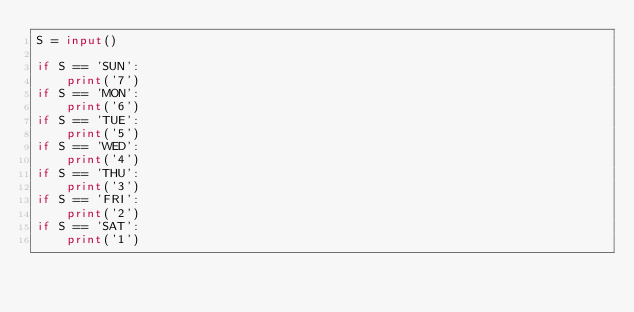Convert code to text. <code><loc_0><loc_0><loc_500><loc_500><_Python_>S = input()

if S == 'SUN':
    print('7')
if S == 'MON':
    print('6')
if S == 'TUE':
    print('5')
if S == 'WED':
    print('4')
if S == 'THU':
    print('3')
if S == 'FRI':
    print('2')
if S == 'SAT':
    print('1')
</code> 